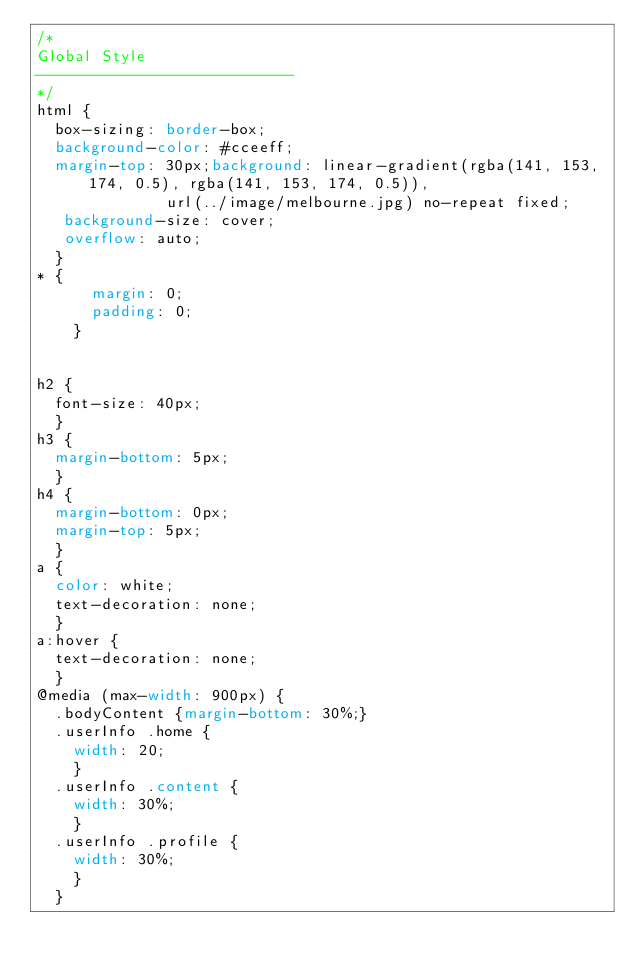<code> <loc_0><loc_0><loc_500><loc_500><_CSS_>/* 
Global Style
----------------------------
*/
html {
	box-sizing: border-box;
	background-color: #cceeff;
	margin-top: 30px;background: linear-gradient(rgba(141, 153, 174, 0.5), rgba(141, 153, 174, 0.5)),
              url(../image/melbourne.jpg) no-repeat fixed;
   background-size: cover;
   overflow: auto;
	}
* {
      margin: 0;
      padding: 0;
    }


h2 {
	font-size: 40px;
	}
h3 {
	margin-bottom: 5px;
	}
h4 {
	margin-bottom: 0px;
	margin-top: 5px;
	}
a {
  color: white;
  text-decoration: none;
	}
a:hover {
  text-decoration: none;
	}
@media (max-width: 900px) {
	.bodyContent {margin-bottom: 30%;}
	.userInfo .home {
		width: 20;
		}
	.userInfo .content {
		width: 30%;
		}
	.userInfo .profile {
		width: 30%;
		}
	}</code> 